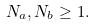Convert formula to latex. <formula><loc_0><loc_0><loc_500><loc_500>N _ { a } , N _ { b } \geq 1 .</formula> 